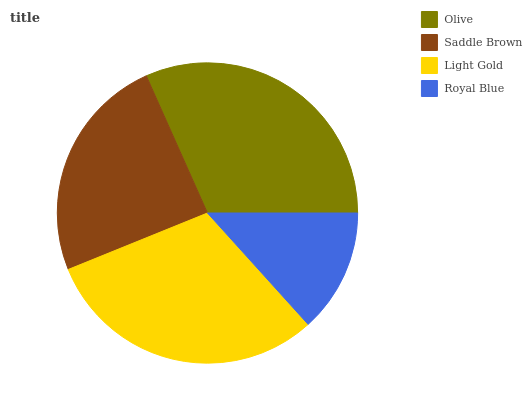Is Royal Blue the minimum?
Answer yes or no. Yes. Is Olive the maximum?
Answer yes or no. Yes. Is Saddle Brown the minimum?
Answer yes or no. No. Is Saddle Brown the maximum?
Answer yes or no. No. Is Olive greater than Saddle Brown?
Answer yes or no. Yes. Is Saddle Brown less than Olive?
Answer yes or no. Yes. Is Saddle Brown greater than Olive?
Answer yes or no. No. Is Olive less than Saddle Brown?
Answer yes or no. No. Is Light Gold the high median?
Answer yes or no. Yes. Is Saddle Brown the low median?
Answer yes or no. Yes. Is Olive the high median?
Answer yes or no. No. Is Olive the low median?
Answer yes or no. No. 